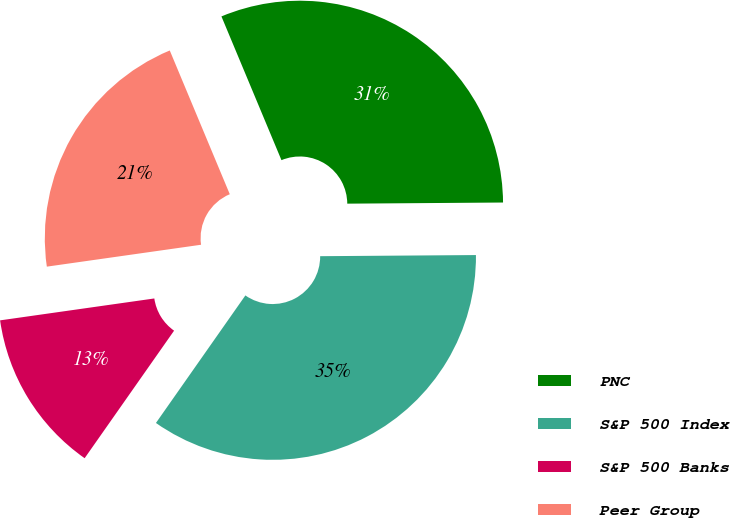<chart> <loc_0><loc_0><loc_500><loc_500><pie_chart><fcel>PNC<fcel>S&P 500 Index<fcel>S&P 500 Banks<fcel>Peer Group<nl><fcel>31.18%<fcel>34.85%<fcel>13.02%<fcel>20.95%<nl></chart> 